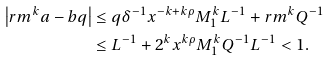Convert formula to latex. <formula><loc_0><loc_0><loc_500><loc_500>\left | r m ^ { k } a - b q \right | & \leq q \delta ^ { - 1 } x ^ { - k + k \rho } M _ { 1 } ^ { k } L ^ { - 1 } + r m ^ { k } Q ^ { - 1 } \\ & \leq L ^ { - 1 } + 2 ^ { k } x ^ { k \rho } M _ { 1 } ^ { k } Q ^ { - 1 } L ^ { - 1 } < 1 .</formula> 